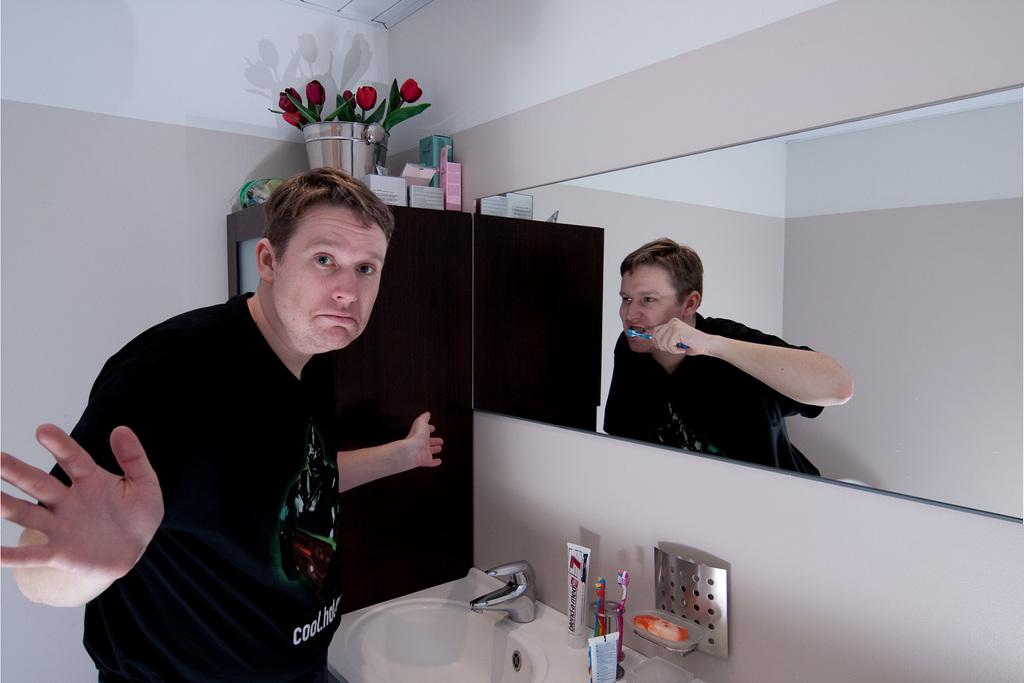What is the "c" word on his shirt?
Ensure brevity in your answer.  Cool. 